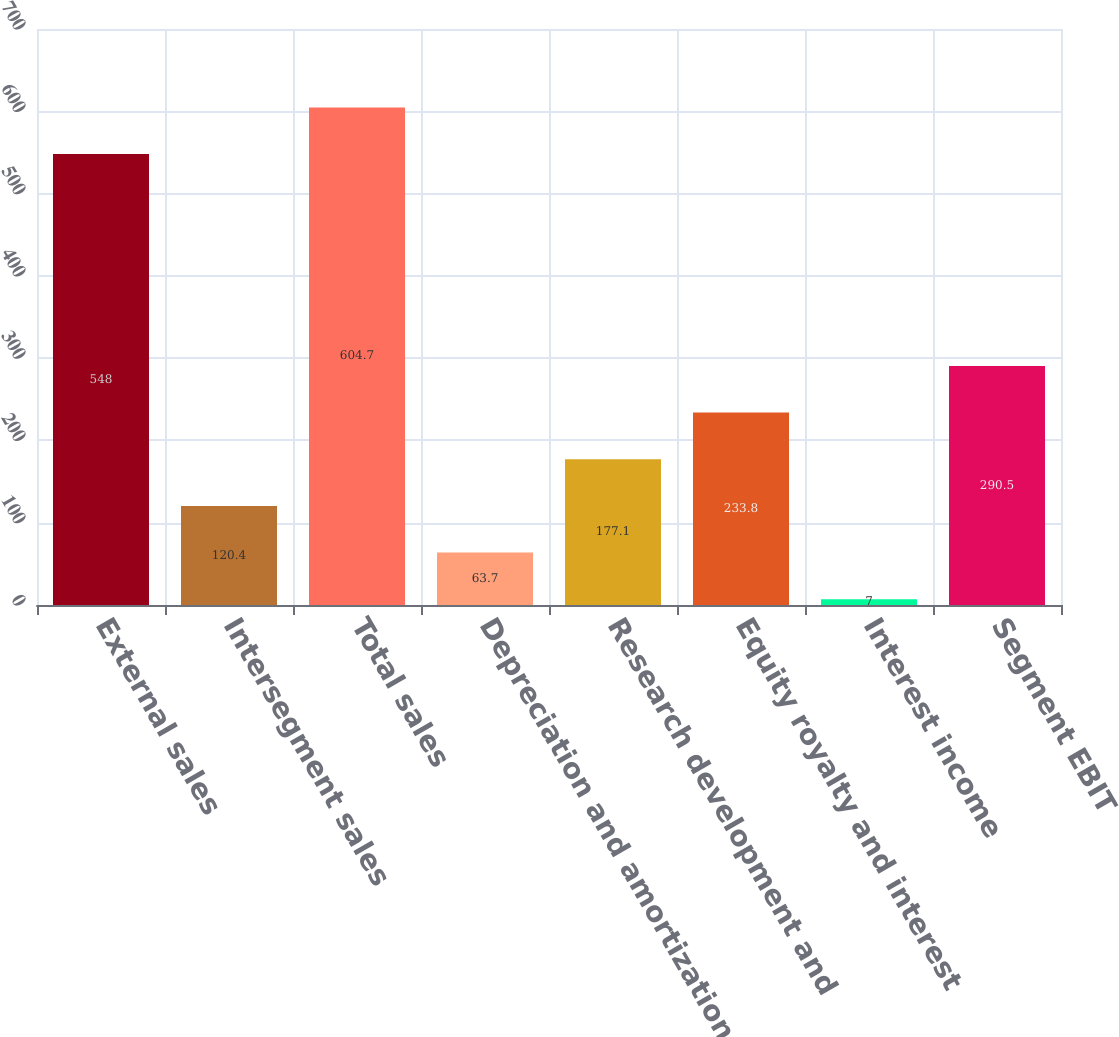Convert chart to OTSL. <chart><loc_0><loc_0><loc_500><loc_500><bar_chart><fcel>External sales<fcel>Intersegment sales<fcel>Total sales<fcel>Depreciation and amortization<fcel>Research development and<fcel>Equity royalty and interest<fcel>Interest income<fcel>Segment EBIT<nl><fcel>548<fcel>120.4<fcel>604.7<fcel>63.7<fcel>177.1<fcel>233.8<fcel>7<fcel>290.5<nl></chart> 